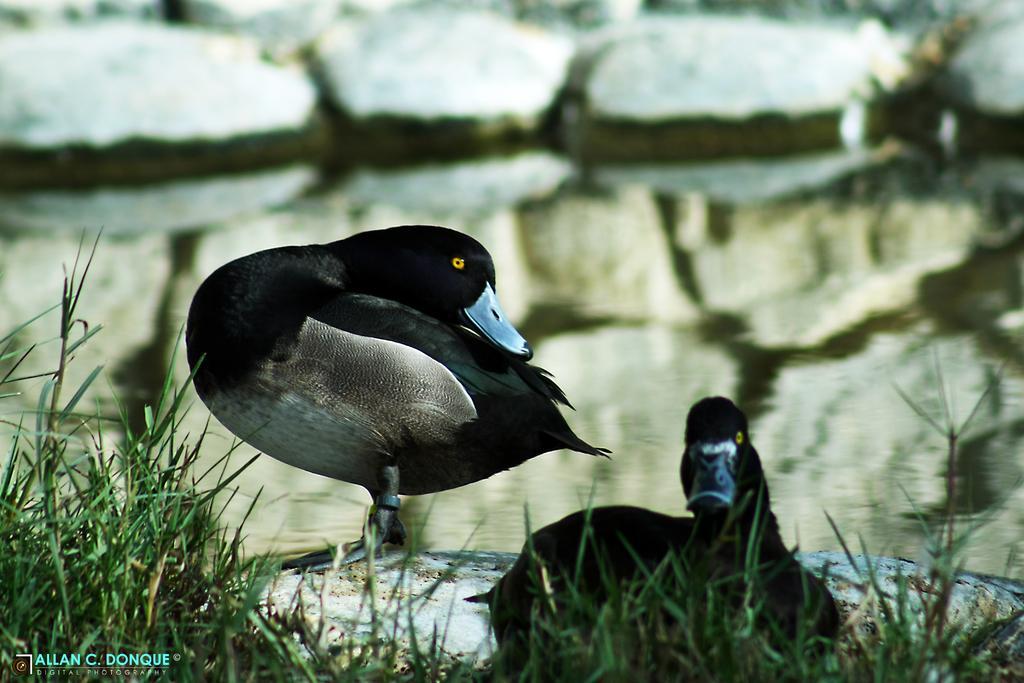Could you give a brief overview of what you see in this image? In this image I can see two birds in black,white,brown color. I can see the green grass,rock and water. 